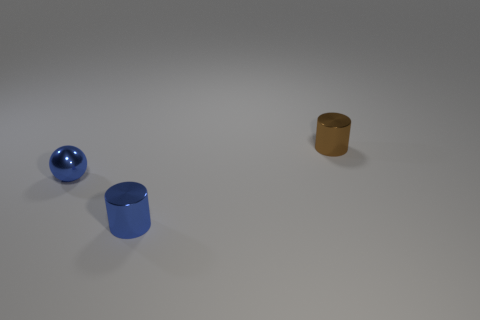Is there a tiny blue metallic object of the same shape as the tiny brown metal thing?
Your answer should be compact. Yes. What number of objects are balls or yellow rubber cubes?
Your answer should be very brief. 1. There is a small blue shiny object behind the small metallic cylinder in front of the brown object; how many spheres are in front of it?
Offer a very short reply. 0. There is another thing that is the same shape as the small brown metallic object; what material is it?
Give a very brief answer. Metal. The object that is behind the blue cylinder and on the right side of the sphere is made of what material?
Keep it short and to the point. Metal. Are there fewer tiny blue shiny cylinders behind the brown metallic object than blue metallic objects that are behind the small blue cylinder?
Your answer should be very brief. Yes. What number of other things are there of the same size as the blue cylinder?
Provide a short and direct response. 2. What shape is the tiny metallic thing that is to the right of the small cylinder in front of the tiny blue shiny sphere to the left of the small blue cylinder?
Provide a short and direct response. Cylinder. How many brown objects are either small metallic spheres or cylinders?
Make the answer very short. 1. How many cylinders are behind the shiny cylinder in front of the sphere?
Offer a very short reply. 1. 